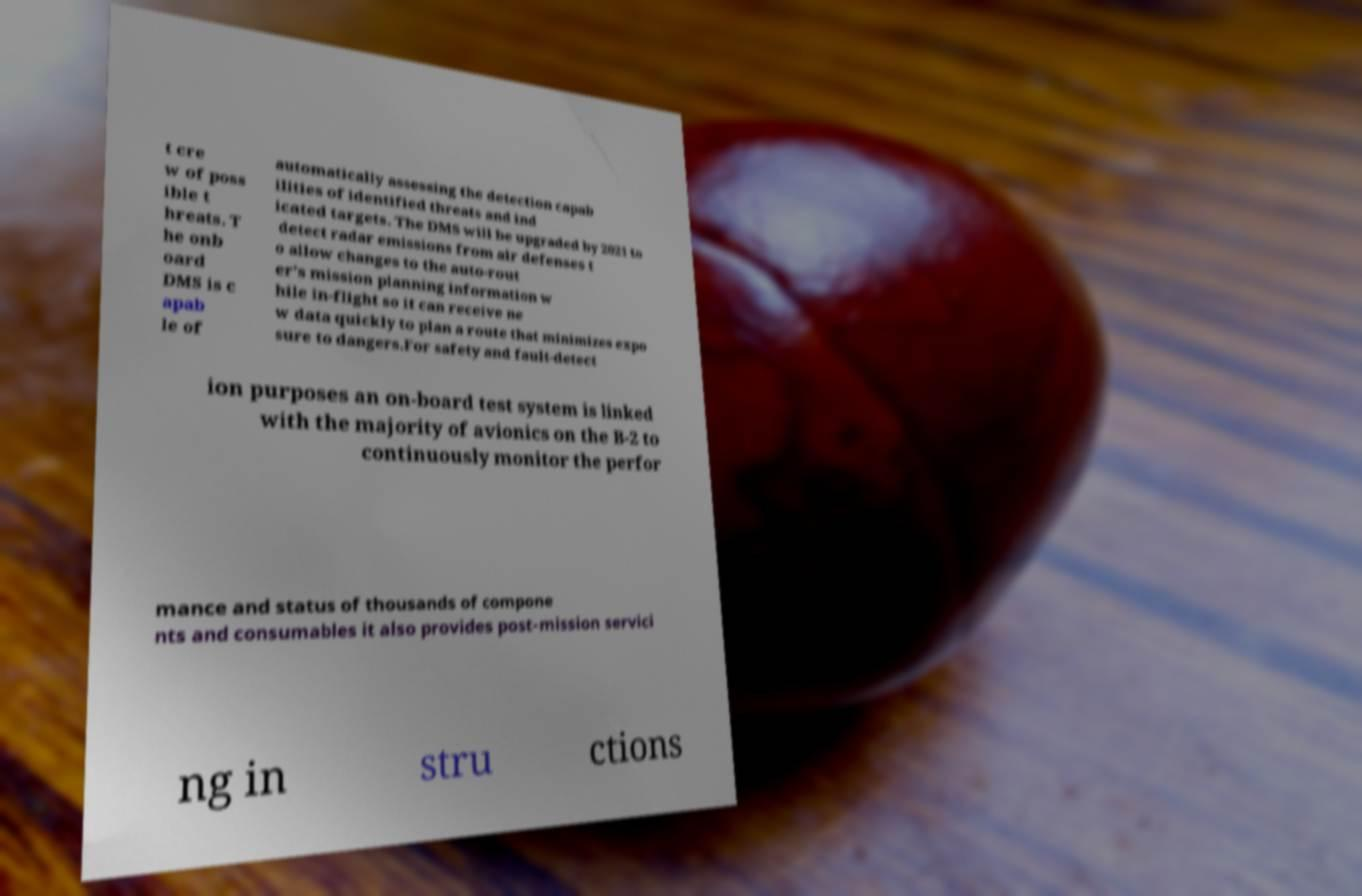Please read and relay the text visible in this image. What does it say? t cre w of poss ible t hreats. T he onb oard DMS is c apab le of automatically assessing the detection capab ilities of identified threats and ind icated targets. The DMS will be upgraded by 2021 to detect radar emissions from air defenses t o allow changes to the auto-rout er's mission planning information w hile in-flight so it can receive ne w data quickly to plan a route that minimizes expo sure to dangers.For safety and fault-detect ion purposes an on-board test system is linked with the majority of avionics on the B-2 to continuously monitor the perfor mance and status of thousands of compone nts and consumables it also provides post-mission servici ng in stru ctions 